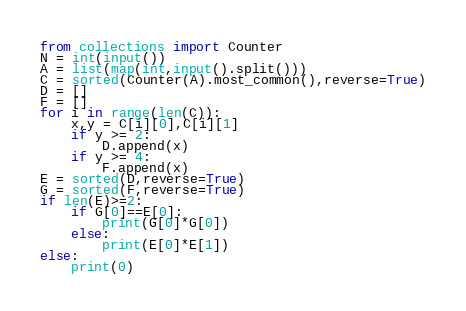Convert code to text. <code><loc_0><loc_0><loc_500><loc_500><_Python_>from collections import Counter
N = int(input())
A = list(map(int,input().split()))
C = sorted(Counter(A).most_common(),reverse=True)
D = []
F = []
for i in range(len(C)):
    x,y = C[i][0],C[i][1]
    if y >= 2:
        D.append(x)
    if y >= 4:
        F.append(x)
E = sorted(D,reverse=True)
G = sorted(F,reverse=True)
if len(E)>=2:
    if G[0]==E[0]:
        print(G[0]*G[0])
    else:
        print(E[0]*E[1])
else:
    print(0)</code> 